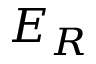<formula> <loc_0><loc_0><loc_500><loc_500>E _ { R }</formula> 